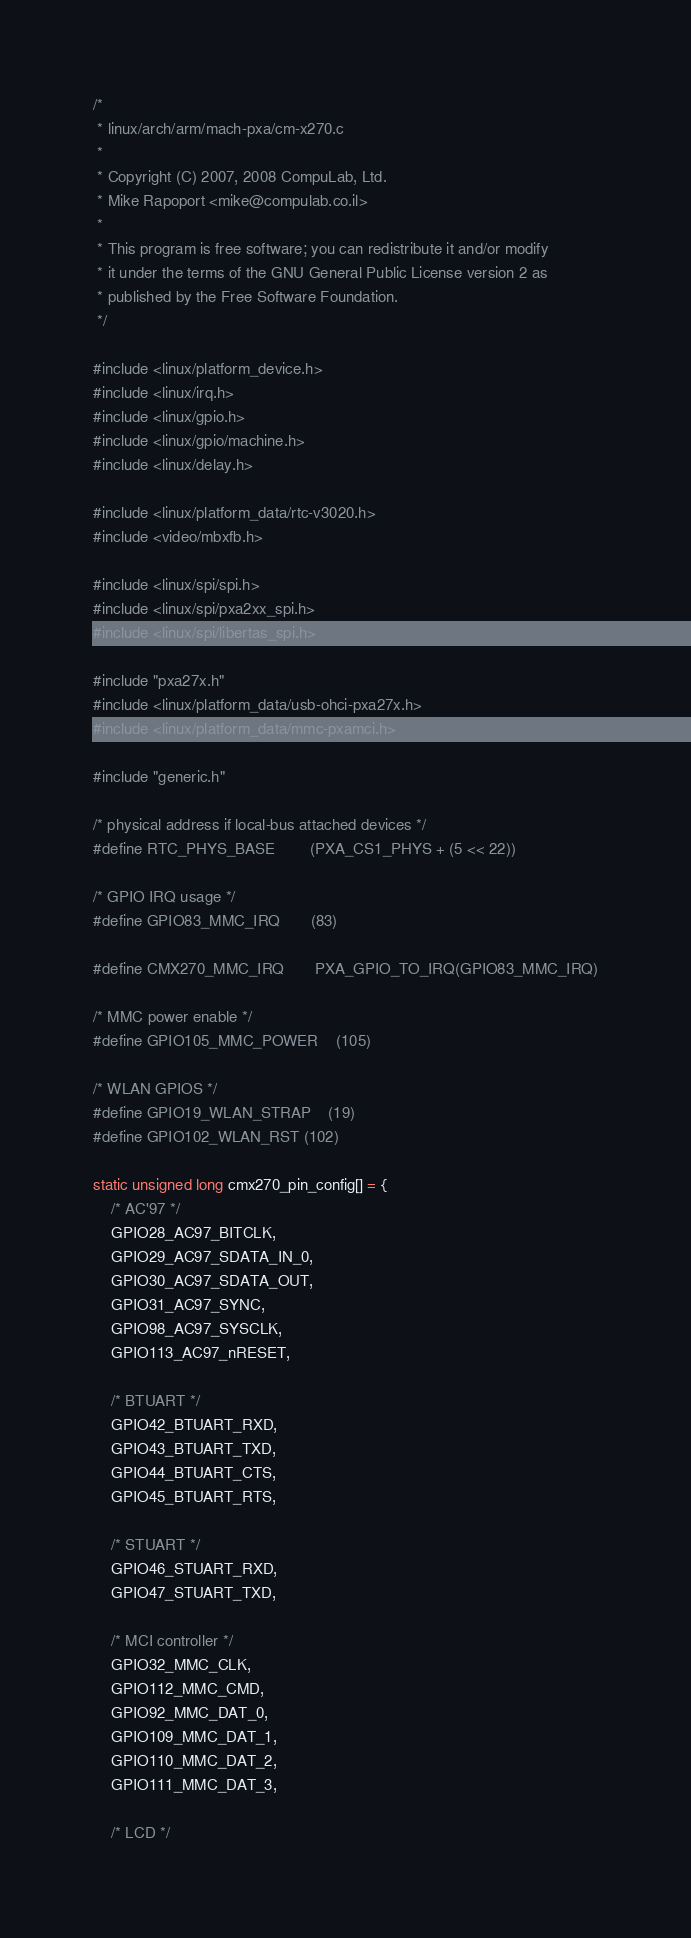<code> <loc_0><loc_0><loc_500><loc_500><_C_>/*
 * linux/arch/arm/mach-pxa/cm-x270.c
 *
 * Copyright (C) 2007, 2008 CompuLab, Ltd.
 * Mike Rapoport <mike@compulab.co.il>
 *
 * This program is free software; you can redistribute it and/or modify
 * it under the terms of the GNU General Public License version 2 as
 * published by the Free Software Foundation.
 */

#include <linux/platform_device.h>
#include <linux/irq.h>
#include <linux/gpio.h>
#include <linux/gpio/machine.h>
#include <linux/delay.h>

#include <linux/platform_data/rtc-v3020.h>
#include <video/mbxfb.h>

#include <linux/spi/spi.h>
#include <linux/spi/pxa2xx_spi.h>
#include <linux/spi/libertas_spi.h>

#include "pxa27x.h"
#include <linux/platform_data/usb-ohci-pxa27x.h>
#include <linux/platform_data/mmc-pxamci.h>

#include "generic.h"

/* physical address if local-bus attached devices */
#define RTC_PHYS_BASE		(PXA_CS1_PHYS + (5 << 22))

/* GPIO IRQ usage */
#define GPIO83_MMC_IRQ		(83)

#define CMX270_MMC_IRQ		PXA_GPIO_TO_IRQ(GPIO83_MMC_IRQ)

/* MMC power enable */
#define GPIO105_MMC_POWER	(105)

/* WLAN GPIOS */
#define GPIO19_WLAN_STRAP	(19)
#define GPIO102_WLAN_RST	(102)

static unsigned long cmx270_pin_config[] = {
	/* AC'97 */
	GPIO28_AC97_BITCLK,
	GPIO29_AC97_SDATA_IN_0,
	GPIO30_AC97_SDATA_OUT,
	GPIO31_AC97_SYNC,
	GPIO98_AC97_SYSCLK,
	GPIO113_AC97_nRESET,

	/* BTUART */
	GPIO42_BTUART_RXD,
	GPIO43_BTUART_TXD,
	GPIO44_BTUART_CTS,
	GPIO45_BTUART_RTS,

	/* STUART */
	GPIO46_STUART_RXD,
	GPIO47_STUART_TXD,

	/* MCI controller */
	GPIO32_MMC_CLK,
	GPIO112_MMC_CMD,
	GPIO92_MMC_DAT_0,
	GPIO109_MMC_DAT_1,
	GPIO110_MMC_DAT_2,
	GPIO111_MMC_DAT_3,

	/* LCD */</code> 